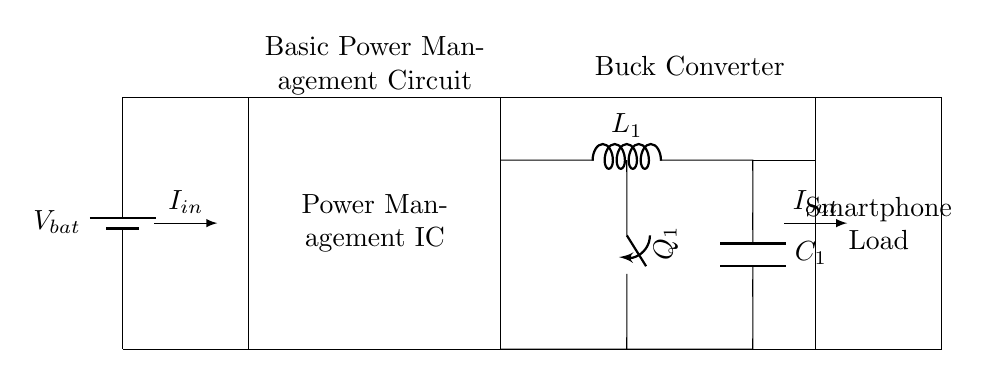What type of circuit is shown? The diagram represents a basic power management circuit, which is designed to manage and optimize power delivery, especially for mobile devices.
Answer: Basic power management circuit What is the function of the buck converter? The buck converter steps down the voltage from the battery to a lower voltage suitable for the smartphone load. This is essential for efficient power management.
Answer: Step-down voltage conversion What is the component symbol for the battery? In the diagram, the battery is represented by a symbol commonly used for batteries, which typically includes two lines with one being longer and labeled with voltage notation.
Answer: Battery symbol What is the current flowing into the circuit labeled as? The current entering the circuit from the battery is labeled as I in. This is a typical notation to signify the input current for circuits.
Answer: I in How does the output current relate to the input current? The output current (labeled I out) flows to the smartphone load, which is expected to be less than or equal to the input current, depending on the efficiency of the buck converter and load requirements.
Answer: Output current What component is denoted as L1? In the circuit, L1 represents an inductor, which is used in the buck converter to filter and smooth the current, reducing voltage ripple and stabilizing the output.
Answer: Inductor What does C1 represent in this circuit? C1 in the diagram represents a capacitor, which is typically used to store charge and help smooth out fluctuations in voltage, further stabilizing the output to the load.
Answer: Capacitor 